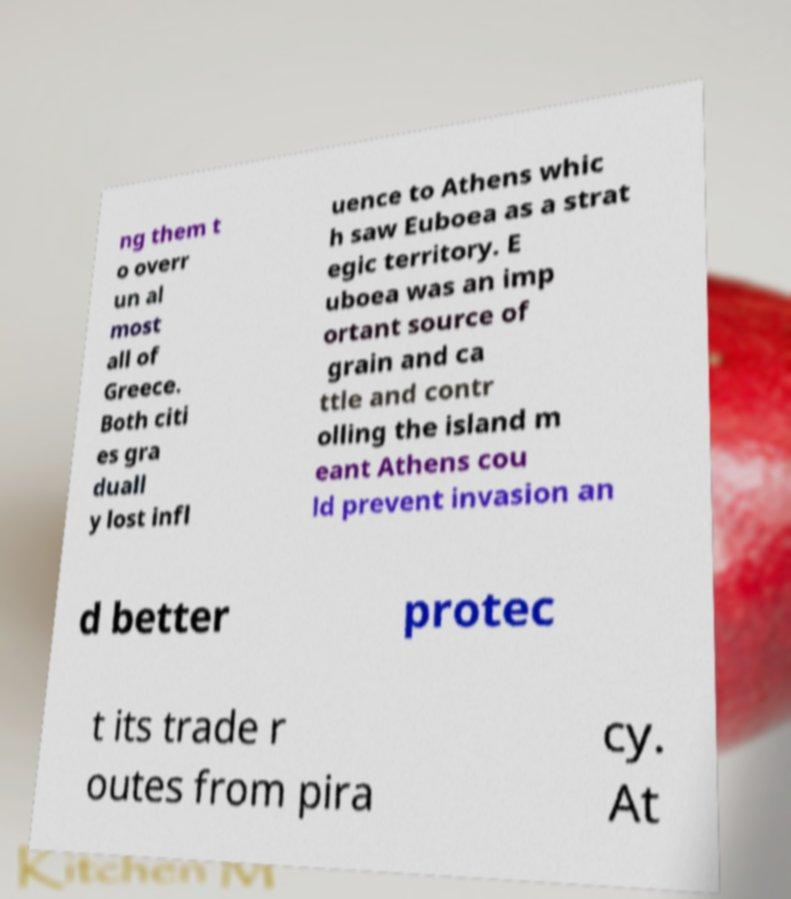For documentation purposes, I need the text within this image transcribed. Could you provide that? ng them t o overr un al most all of Greece. Both citi es gra duall y lost infl uence to Athens whic h saw Euboea as a strat egic territory. E uboea was an imp ortant source of grain and ca ttle and contr olling the island m eant Athens cou ld prevent invasion an d better protec t its trade r outes from pira cy. At 